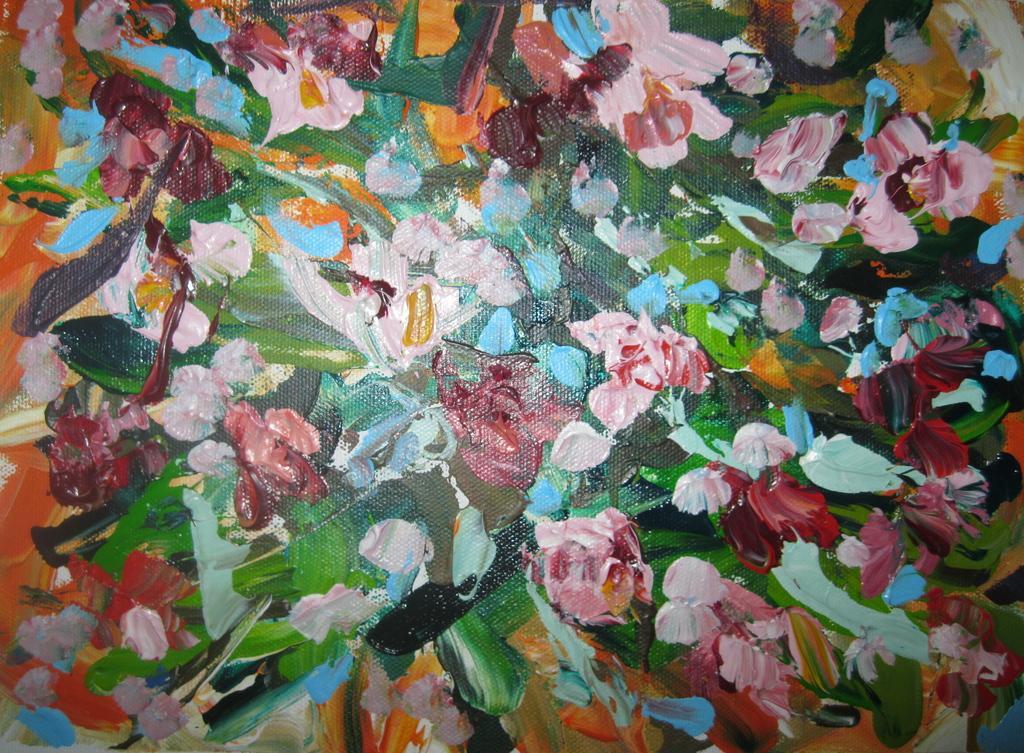Can you describe this image briefly? In this image I can see painting of something. The painting has different colors. 